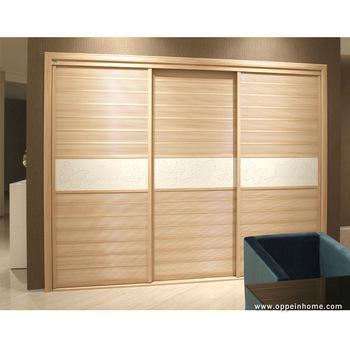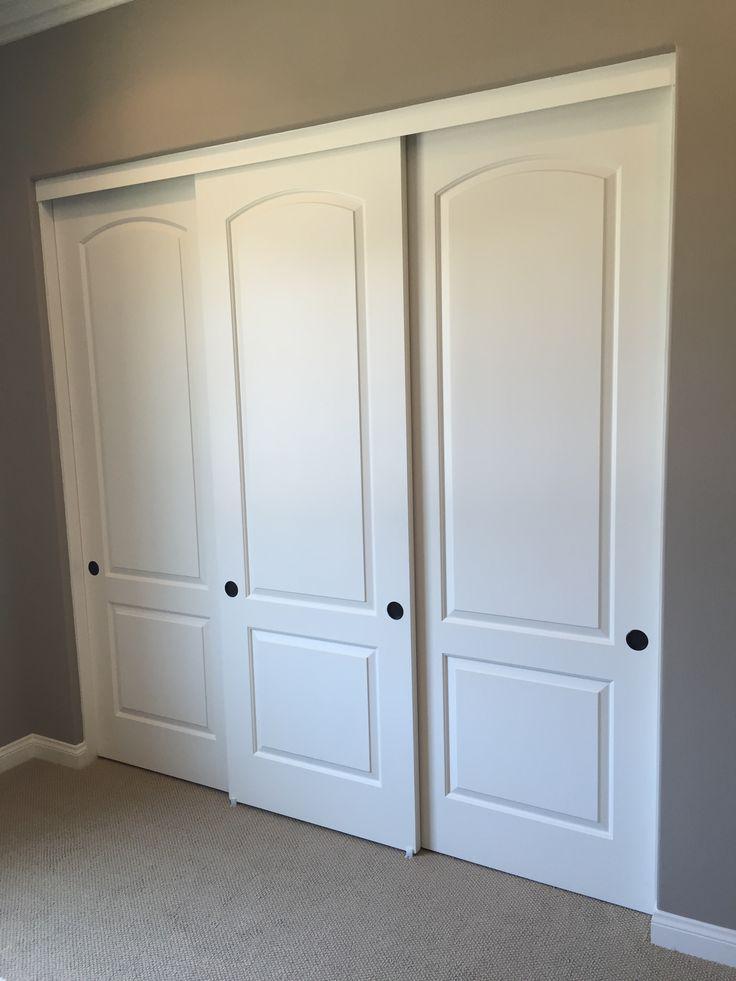The first image is the image on the left, the second image is the image on the right. Examine the images to the left and right. Is the description "An image shows a three-section white sliding door unit with round dark handles." accurate? Answer yes or no. Yes. The first image is the image on the left, the second image is the image on the right. Assess this claim about the two images: "One three panel door has visible hardware on each door and a second three panel door has a contrasting middle band and no visible hardware.". Correct or not? Answer yes or no. Yes. 